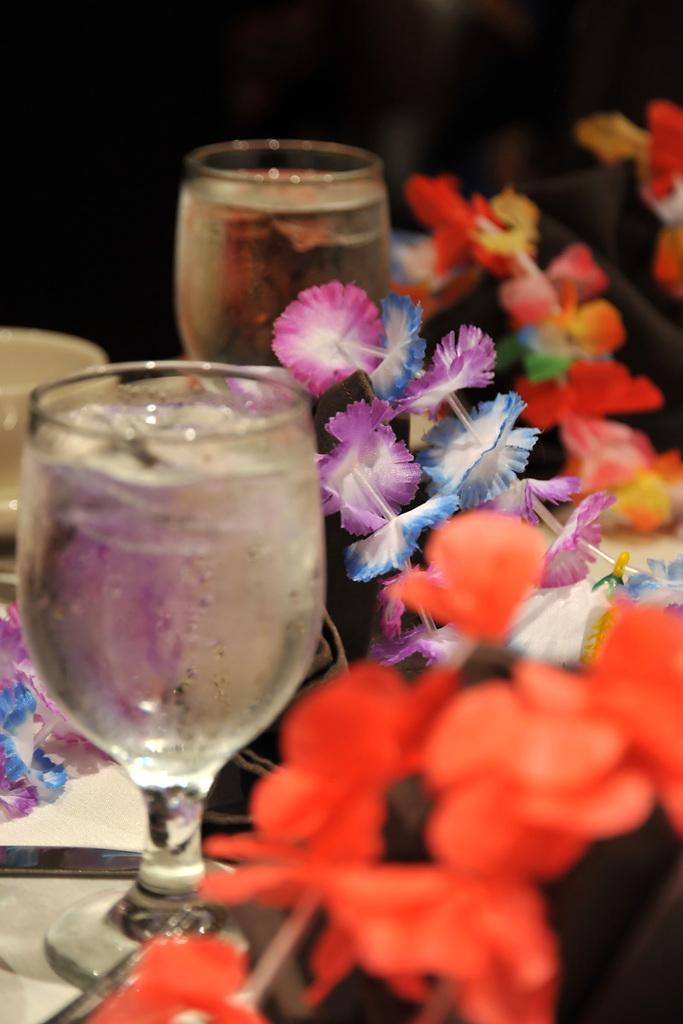Please provide a concise description of this image. In this image there is a glass, cup and few artificial flowers. Beside the glass there is a knife on plate. Glasses are filled with drink. Background is blurry. 